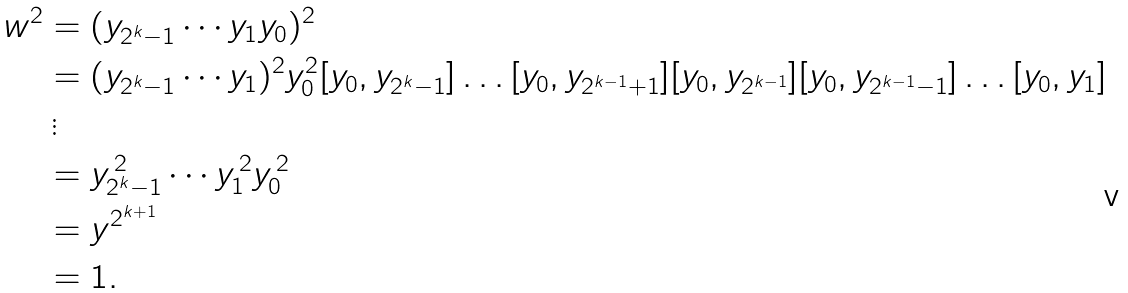Convert formula to latex. <formula><loc_0><loc_0><loc_500><loc_500>w ^ { 2 } & = ( y _ { 2 ^ { k } - 1 } \cdots y _ { 1 } y _ { 0 } ) ^ { 2 } \\ & = ( y _ { 2 ^ { k } - 1 } \cdots y _ { 1 } ) ^ { 2 } y _ { 0 } ^ { 2 } [ y _ { 0 } , y _ { 2 ^ { k } - 1 } ] \dots [ y _ { 0 } , y _ { 2 ^ { k - 1 } + 1 } ] [ y _ { 0 } , y _ { 2 ^ { k - 1 } } ] [ y _ { 0 } , y _ { 2 ^ { k - 1 } - 1 } ] \dots [ y _ { 0 } , y _ { 1 } ] \\ & \, \vdots \\ & = y _ { 2 ^ { k } - 1 } ^ { \, 2 } \cdots y _ { 1 } ^ { \, 2 } y _ { 0 } ^ { \, 2 } \\ & = y ^ { 2 ^ { k + 1 } } \\ & = 1 .</formula> 